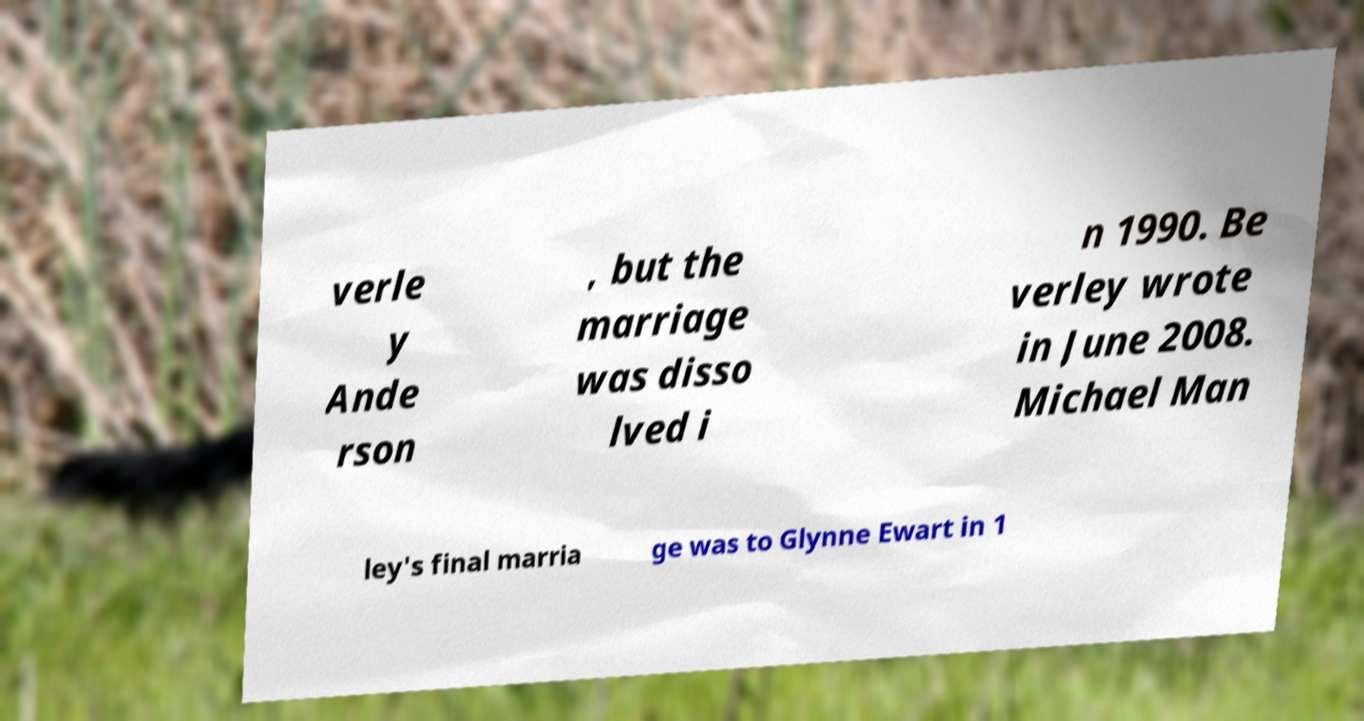Please read and relay the text visible in this image. What does it say? verle y Ande rson , but the marriage was disso lved i n 1990. Be verley wrote in June 2008. Michael Man ley's final marria ge was to Glynne Ewart in 1 